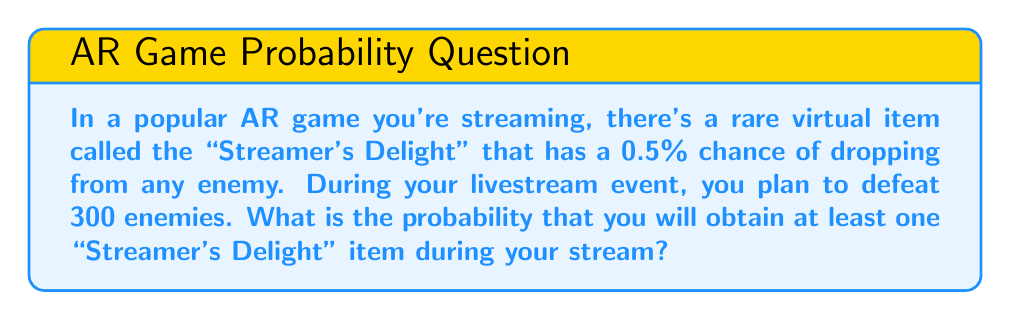Show me your answer to this math problem. Let's approach this step-by-step:

1) First, let's define our probability:
   $p$ = probability of getting the item from one enemy = 0.5% = 0.005
   $n$ = number of enemies = 300

2) It's easier to calculate the probability of not getting the item and then subtract from 1:
   P(at least one item) = 1 - P(no items)

3) The probability of not getting the item from one enemy is:
   $1 - p = 1 - 0.005 = 0.995$

4) For all 300 enemies, we need this to happen every time. Since each enemy is independent, we multiply these probabilities:
   P(no items) = $(0.995)^{300}$

5) Now we can calculate:
   P(at least one item) = $1 - (0.995)^{300}$

6) Using a calculator (as this is a complex calculation):
   $(0.995)^{300} \approx 0.2231$

7) Therefore:
   P(at least one item) = $1 - 0.2231 \approx 0.7769$

8) Convert to percentage:
   0.7769 * 100% ≈ 77.69%
Answer: 77.69% 